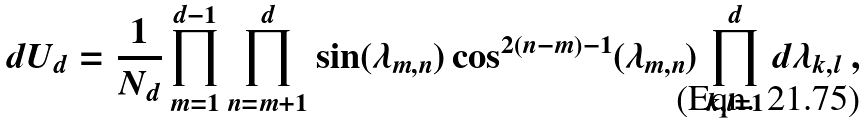Convert formula to latex. <formula><loc_0><loc_0><loc_500><loc_500>d U _ { d } = \frac { 1 } { N _ { d } } \prod _ { m = 1 } ^ { d - 1 } \prod _ { n = m + 1 } ^ { d } \sin ( \lambda _ { m , n } ) \cos ^ { 2 ( n - m ) - 1 } ( \lambda _ { m , n } ) \prod _ { k , l = 1 } ^ { d } d \lambda _ { k , l } \ ,</formula> 